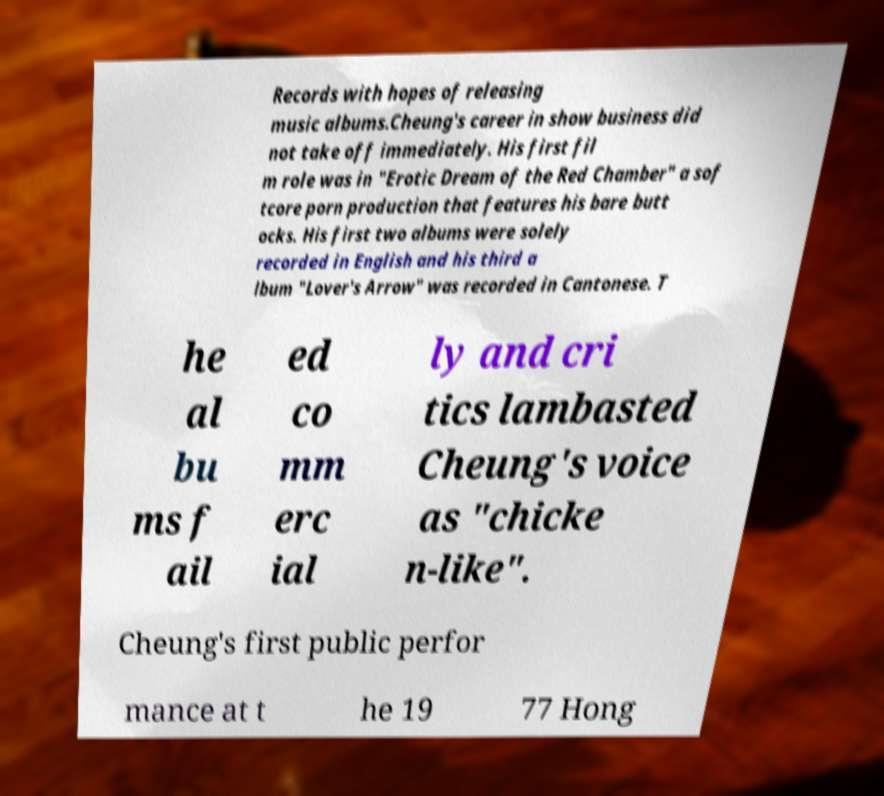Could you assist in decoding the text presented in this image and type it out clearly? Records with hopes of releasing music albums.Cheung's career in show business did not take off immediately. His first fil m role was in "Erotic Dream of the Red Chamber" a sof tcore porn production that features his bare butt ocks. His first two albums were solely recorded in English and his third a lbum "Lover's Arrow" was recorded in Cantonese. T he al bu ms f ail ed co mm erc ial ly and cri tics lambasted Cheung's voice as "chicke n-like". Cheung's first public perfor mance at t he 19 77 Hong 